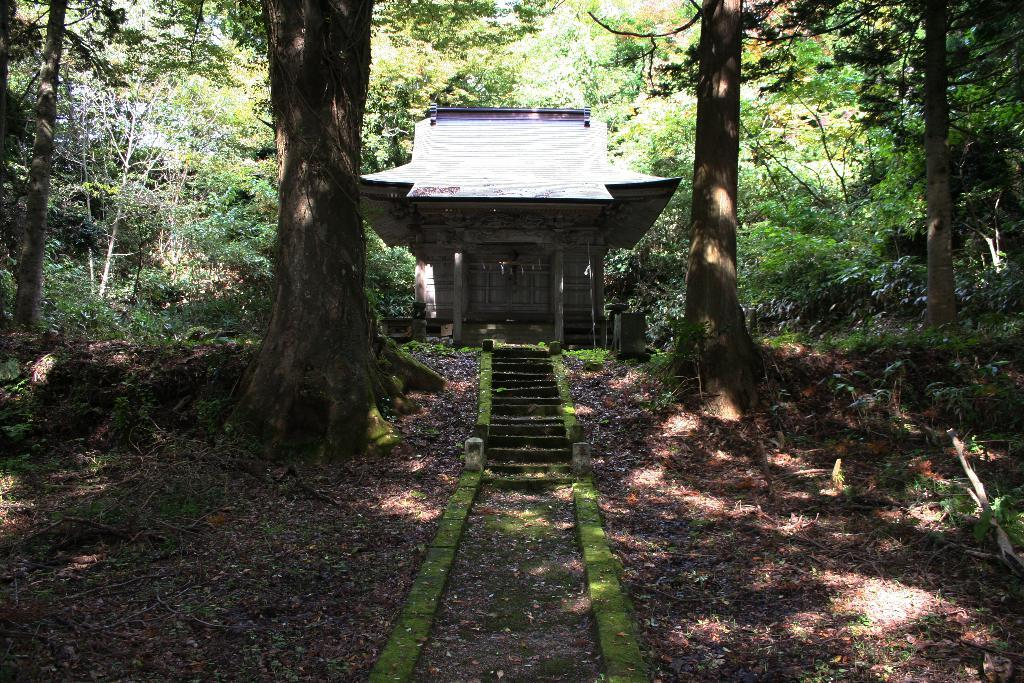What type of structure can be seen in the background of the image? There is a house in the background of the image. What other natural elements are visible in the background? There are trees in the background of the image. What is the ground made of in the front of the image? There is grass on the ground in the front of the image. What additional objects can be found on the ground in the front of the image? Dry leaves are present in the front of the image. What type of veil is draped over the trees in the image? There is no veil present in the image; the trees are not covered by any fabric or material. 